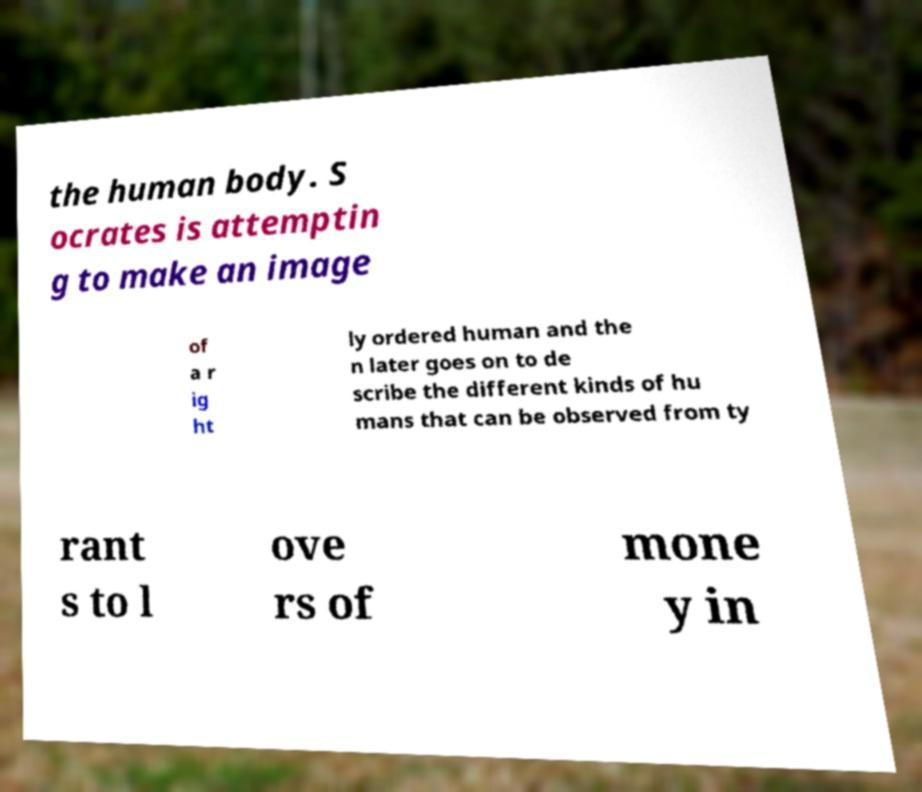Could you assist in decoding the text presented in this image and type it out clearly? the human body. S ocrates is attemptin g to make an image of a r ig ht ly ordered human and the n later goes on to de scribe the different kinds of hu mans that can be observed from ty rant s to l ove rs of mone y in 